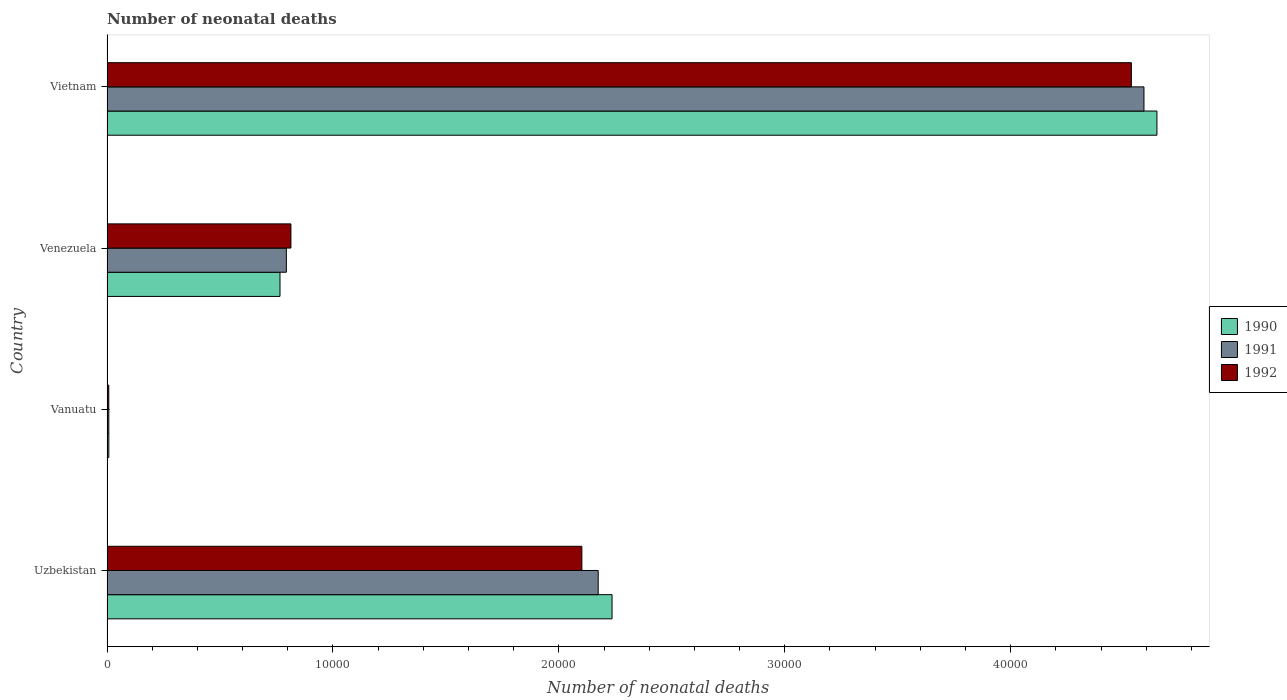Are the number of bars per tick equal to the number of legend labels?
Provide a succinct answer. Yes. Are the number of bars on each tick of the Y-axis equal?
Ensure brevity in your answer.  Yes. What is the label of the 4th group of bars from the top?
Give a very brief answer. Uzbekistan. What is the number of neonatal deaths in in 1990 in Uzbekistan?
Offer a very short reply. 2.24e+04. Across all countries, what is the maximum number of neonatal deaths in in 1992?
Your answer should be compact. 4.53e+04. Across all countries, what is the minimum number of neonatal deaths in in 1992?
Make the answer very short. 79. In which country was the number of neonatal deaths in in 1992 maximum?
Offer a terse response. Vietnam. In which country was the number of neonatal deaths in in 1991 minimum?
Your answer should be compact. Vanuatu. What is the total number of neonatal deaths in in 1992 in the graph?
Offer a very short reply. 7.46e+04. What is the difference between the number of neonatal deaths in in 1990 in Vanuatu and that in Venezuela?
Make the answer very short. -7576. What is the difference between the number of neonatal deaths in in 1992 in Vietnam and the number of neonatal deaths in in 1991 in Uzbekistan?
Your answer should be compact. 2.36e+04. What is the average number of neonatal deaths in in 1991 per country?
Your response must be concise. 1.89e+04. What is the difference between the number of neonatal deaths in in 1991 and number of neonatal deaths in in 1990 in Vietnam?
Give a very brief answer. -574. In how many countries, is the number of neonatal deaths in in 1990 greater than 42000 ?
Offer a very short reply. 1. What is the ratio of the number of neonatal deaths in in 1992 in Uzbekistan to that in Vanuatu?
Your answer should be compact. 266.06. Is the difference between the number of neonatal deaths in in 1991 in Uzbekistan and Venezuela greater than the difference between the number of neonatal deaths in in 1990 in Uzbekistan and Venezuela?
Your answer should be compact. No. What is the difference between the highest and the second highest number of neonatal deaths in in 1992?
Your answer should be compact. 2.43e+04. What is the difference between the highest and the lowest number of neonatal deaths in in 1992?
Offer a very short reply. 4.53e+04. What does the 3rd bar from the bottom in Uzbekistan represents?
Make the answer very short. 1992. Is it the case that in every country, the sum of the number of neonatal deaths in in 1992 and number of neonatal deaths in in 1990 is greater than the number of neonatal deaths in in 1991?
Provide a short and direct response. Yes. How many countries are there in the graph?
Offer a terse response. 4. What is the difference between two consecutive major ticks on the X-axis?
Your answer should be compact. 10000. Where does the legend appear in the graph?
Provide a succinct answer. Center right. How many legend labels are there?
Offer a very short reply. 3. What is the title of the graph?
Offer a terse response. Number of neonatal deaths. Does "2006" appear as one of the legend labels in the graph?
Your answer should be compact. No. What is the label or title of the X-axis?
Provide a short and direct response. Number of neonatal deaths. What is the Number of neonatal deaths of 1990 in Uzbekistan?
Make the answer very short. 2.24e+04. What is the Number of neonatal deaths of 1991 in Uzbekistan?
Provide a short and direct response. 2.17e+04. What is the Number of neonatal deaths of 1992 in Uzbekistan?
Your response must be concise. 2.10e+04. What is the Number of neonatal deaths of 1990 in Vanuatu?
Your answer should be very brief. 81. What is the Number of neonatal deaths of 1991 in Vanuatu?
Your answer should be compact. 80. What is the Number of neonatal deaths in 1992 in Vanuatu?
Ensure brevity in your answer.  79. What is the Number of neonatal deaths in 1990 in Venezuela?
Give a very brief answer. 7657. What is the Number of neonatal deaths in 1991 in Venezuela?
Your response must be concise. 7939. What is the Number of neonatal deaths in 1992 in Venezuela?
Your answer should be very brief. 8141. What is the Number of neonatal deaths in 1990 in Vietnam?
Provide a succinct answer. 4.65e+04. What is the Number of neonatal deaths in 1991 in Vietnam?
Provide a short and direct response. 4.59e+04. What is the Number of neonatal deaths in 1992 in Vietnam?
Offer a terse response. 4.53e+04. Across all countries, what is the maximum Number of neonatal deaths of 1990?
Provide a short and direct response. 4.65e+04. Across all countries, what is the maximum Number of neonatal deaths of 1991?
Give a very brief answer. 4.59e+04. Across all countries, what is the maximum Number of neonatal deaths of 1992?
Your response must be concise. 4.53e+04. Across all countries, what is the minimum Number of neonatal deaths in 1992?
Provide a short and direct response. 79. What is the total Number of neonatal deaths in 1990 in the graph?
Provide a short and direct response. 7.66e+04. What is the total Number of neonatal deaths in 1991 in the graph?
Offer a terse response. 7.57e+04. What is the total Number of neonatal deaths of 1992 in the graph?
Provide a succinct answer. 7.46e+04. What is the difference between the Number of neonatal deaths in 1990 in Uzbekistan and that in Vanuatu?
Keep it short and to the point. 2.23e+04. What is the difference between the Number of neonatal deaths of 1991 in Uzbekistan and that in Vanuatu?
Provide a succinct answer. 2.17e+04. What is the difference between the Number of neonatal deaths in 1992 in Uzbekistan and that in Vanuatu?
Your answer should be very brief. 2.09e+04. What is the difference between the Number of neonatal deaths in 1990 in Uzbekistan and that in Venezuela?
Your answer should be very brief. 1.47e+04. What is the difference between the Number of neonatal deaths in 1991 in Uzbekistan and that in Venezuela?
Make the answer very short. 1.38e+04. What is the difference between the Number of neonatal deaths of 1992 in Uzbekistan and that in Venezuela?
Make the answer very short. 1.29e+04. What is the difference between the Number of neonatal deaths of 1990 in Uzbekistan and that in Vietnam?
Provide a succinct answer. -2.41e+04. What is the difference between the Number of neonatal deaths in 1991 in Uzbekistan and that in Vietnam?
Ensure brevity in your answer.  -2.42e+04. What is the difference between the Number of neonatal deaths in 1992 in Uzbekistan and that in Vietnam?
Your response must be concise. -2.43e+04. What is the difference between the Number of neonatal deaths in 1990 in Vanuatu and that in Venezuela?
Keep it short and to the point. -7576. What is the difference between the Number of neonatal deaths in 1991 in Vanuatu and that in Venezuela?
Make the answer very short. -7859. What is the difference between the Number of neonatal deaths in 1992 in Vanuatu and that in Venezuela?
Give a very brief answer. -8062. What is the difference between the Number of neonatal deaths in 1990 in Vanuatu and that in Vietnam?
Your answer should be very brief. -4.64e+04. What is the difference between the Number of neonatal deaths of 1991 in Vanuatu and that in Vietnam?
Your response must be concise. -4.58e+04. What is the difference between the Number of neonatal deaths in 1992 in Vanuatu and that in Vietnam?
Keep it short and to the point. -4.53e+04. What is the difference between the Number of neonatal deaths in 1990 in Venezuela and that in Vietnam?
Your answer should be very brief. -3.88e+04. What is the difference between the Number of neonatal deaths of 1991 in Venezuela and that in Vietnam?
Keep it short and to the point. -3.80e+04. What is the difference between the Number of neonatal deaths in 1992 in Venezuela and that in Vietnam?
Your answer should be very brief. -3.72e+04. What is the difference between the Number of neonatal deaths in 1990 in Uzbekistan and the Number of neonatal deaths in 1991 in Vanuatu?
Your answer should be compact. 2.23e+04. What is the difference between the Number of neonatal deaths of 1990 in Uzbekistan and the Number of neonatal deaths of 1992 in Vanuatu?
Your response must be concise. 2.23e+04. What is the difference between the Number of neonatal deaths of 1991 in Uzbekistan and the Number of neonatal deaths of 1992 in Vanuatu?
Give a very brief answer. 2.17e+04. What is the difference between the Number of neonatal deaths in 1990 in Uzbekistan and the Number of neonatal deaths in 1991 in Venezuela?
Your response must be concise. 1.44e+04. What is the difference between the Number of neonatal deaths of 1990 in Uzbekistan and the Number of neonatal deaths of 1992 in Venezuela?
Provide a short and direct response. 1.42e+04. What is the difference between the Number of neonatal deaths of 1991 in Uzbekistan and the Number of neonatal deaths of 1992 in Venezuela?
Your response must be concise. 1.36e+04. What is the difference between the Number of neonatal deaths of 1990 in Uzbekistan and the Number of neonatal deaths of 1991 in Vietnam?
Your response must be concise. -2.35e+04. What is the difference between the Number of neonatal deaths in 1990 in Uzbekistan and the Number of neonatal deaths in 1992 in Vietnam?
Offer a terse response. -2.30e+04. What is the difference between the Number of neonatal deaths in 1991 in Uzbekistan and the Number of neonatal deaths in 1992 in Vietnam?
Provide a short and direct response. -2.36e+04. What is the difference between the Number of neonatal deaths of 1990 in Vanuatu and the Number of neonatal deaths of 1991 in Venezuela?
Your response must be concise. -7858. What is the difference between the Number of neonatal deaths in 1990 in Vanuatu and the Number of neonatal deaths in 1992 in Venezuela?
Ensure brevity in your answer.  -8060. What is the difference between the Number of neonatal deaths of 1991 in Vanuatu and the Number of neonatal deaths of 1992 in Venezuela?
Offer a very short reply. -8061. What is the difference between the Number of neonatal deaths in 1990 in Vanuatu and the Number of neonatal deaths in 1991 in Vietnam?
Provide a short and direct response. -4.58e+04. What is the difference between the Number of neonatal deaths in 1990 in Vanuatu and the Number of neonatal deaths in 1992 in Vietnam?
Offer a very short reply. -4.53e+04. What is the difference between the Number of neonatal deaths of 1991 in Vanuatu and the Number of neonatal deaths of 1992 in Vietnam?
Your answer should be very brief. -4.53e+04. What is the difference between the Number of neonatal deaths of 1990 in Venezuela and the Number of neonatal deaths of 1991 in Vietnam?
Ensure brevity in your answer.  -3.82e+04. What is the difference between the Number of neonatal deaths in 1990 in Venezuela and the Number of neonatal deaths in 1992 in Vietnam?
Your response must be concise. -3.77e+04. What is the difference between the Number of neonatal deaths of 1991 in Venezuela and the Number of neonatal deaths of 1992 in Vietnam?
Your answer should be compact. -3.74e+04. What is the average Number of neonatal deaths in 1990 per country?
Make the answer very short. 1.91e+04. What is the average Number of neonatal deaths in 1991 per country?
Make the answer very short. 1.89e+04. What is the average Number of neonatal deaths of 1992 per country?
Ensure brevity in your answer.  1.86e+04. What is the difference between the Number of neonatal deaths of 1990 and Number of neonatal deaths of 1991 in Uzbekistan?
Your response must be concise. 613. What is the difference between the Number of neonatal deaths of 1990 and Number of neonatal deaths of 1992 in Uzbekistan?
Offer a very short reply. 1336. What is the difference between the Number of neonatal deaths in 1991 and Number of neonatal deaths in 1992 in Uzbekistan?
Keep it short and to the point. 723. What is the difference between the Number of neonatal deaths of 1990 and Number of neonatal deaths of 1991 in Vanuatu?
Offer a very short reply. 1. What is the difference between the Number of neonatal deaths of 1990 and Number of neonatal deaths of 1992 in Vanuatu?
Your response must be concise. 2. What is the difference between the Number of neonatal deaths in 1991 and Number of neonatal deaths in 1992 in Vanuatu?
Your response must be concise. 1. What is the difference between the Number of neonatal deaths of 1990 and Number of neonatal deaths of 1991 in Venezuela?
Your response must be concise. -282. What is the difference between the Number of neonatal deaths of 1990 and Number of neonatal deaths of 1992 in Venezuela?
Keep it short and to the point. -484. What is the difference between the Number of neonatal deaths of 1991 and Number of neonatal deaths of 1992 in Venezuela?
Offer a terse response. -202. What is the difference between the Number of neonatal deaths of 1990 and Number of neonatal deaths of 1991 in Vietnam?
Ensure brevity in your answer.  574. What is the difference between the Number of neonatal deaths of 1990 and Number of neonatal deaths of 1992 in Vietnam?
Ensure brevity in your answer.  1131. What is the difference between the Number of neonatal deaths in 1991 and Number of neonatal deaths in 1992 in Vietnam?
Your answer should be compact. 557. What is the ratio of the Number of neonatal deaths of 1990 in Uzbekistan to that in Vanuatu?
Your answer should be very brief. 275.99. What is the ratio of the Number of neonatal deaths of 1991 in Uzbekistan to that in Vanuatu?
Keep it short and to the point. 271.77. What is the ratio of the Number of neonatal deaths of 1992 in Uzbekistan to that in Vanuatu?
Keep it short and to the point. 266.06. What is the ratio of the Number of neonatal deaths of 1990 in Uzbekistan to that in Venezuela?
Your answer should be very brief. 2.92. What is the ratio of the Number of neonatal deaths of 1991 in Uzbekistan to that in Venezuela?
Provide a succinct answer. 2.74. What is the ratio of the Number of neonatal deaths in 1992 in Uzbekistan to that in Venezuela?
Provide a short and direct response. 2.58. What is the ratio of the Number of neonatal deaths in 1990 in Uzbekistan to that in Vietnam?
Offer a very short reply. 0.48. What is the ratio of the Number of neonatal deaths in 1991 in Uzbekistan to that in Vietnam?
Keep it short and to the point. 0.47. What is the ratio of the Number of neonatal deaths in 1992 in Uzbekistan to that in Vietnam?
Your response must be concise. 0.46. What is the ratio of the Number of neonatal deaths in 1990 in Vanuatu to that in Venezuela?
Offer a very short reply. 0.01. What is the ratio of the Number of neonatal deaths of 1991 in Vanuatu to that in Venezuela?
Keep it short and to the point. 0.01. What is the ratio of the Number of neonatal deaths of 1992 in Vanuatu to that in Venezuela?
Provide a succinct answer. 0.01. What is the ratio of the Number of neonatal deaths of 1990 in Vanuatu to that in Vietnam?
Offer a very short reply. 0. What is the ratio of the Number of neonatal deaths in 1991 in Vanuatu to that in Vietnam?
Provide a succinct answer. 0. What is the ratio of the Number of neonatal deaths of 1992 in Vanuatu to that in Vietnam?
Offer a terse response. 0. What is the ratio of the Number of neonatal deaths in 1990 in Venezuela to that in Vietnam?
Make the answer very short. 0.16. What is the ratio of the Number of neonatal deaths in 1991 in Venezuela to that in Vietnam?
Provide a short and direct response. 0.17. What is the ratio of the Number of neonatal deaths of 1992 in Venezuela to that in Vietnam?
Give a very brief answer. 0.18. What is the difference between the highest and the second highest Number of neonatal deaths in 1990?
Your response must be concise. 2.41e+04. What is the difference between the highest and the second highest Number of neonatal deaths of 1991?
Provide a short and direct response. 2.42e+04. What is the difference between the highest and the second highest Number of neonatal deaths in 1992?
Offer a terse response. 2.43e+04. What is the difference between the highest and the lowest Number of neonatal deaths in 1990?
Give a very brief answer. 4.64e+04. What is the difference between the highest and the lowest Number of neonatal deaths of 1991?
Your response must be concise. 4.58e+04. What is the difference between the highest and the lowest Number of neonatal deaths in 1992?
Provide a succinct answer. 4.53e+04. 